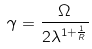Convert formula to latex. <formula><loc_0><loc_0><loc_500><loc_500>\gamma = \frac { \Omega } { 2 \lambda ^ { 1 + \frac { 1 } { R } } }</formula> 